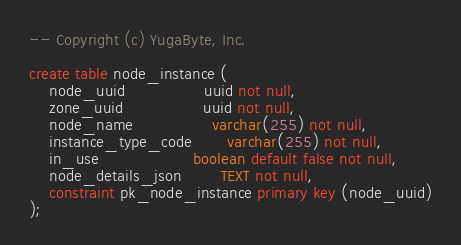Convert code to text. <code><loc_0><loc_0><loc_500><loc_500><_SQL_>-- Copyright (c) YugaByte, Inc.

create table node_instance (
    node_uuid                uuid not null,
    zone_uuid                uuid not null,
    node_name                varchar(255) not null,
    instance_type_code       varchar(255) not null,
    in_use                   boolean default false not null,
    node_details_json        TEXT not null,
    constraint pk_node_instance primary key (node_uuid)
);
</code> 